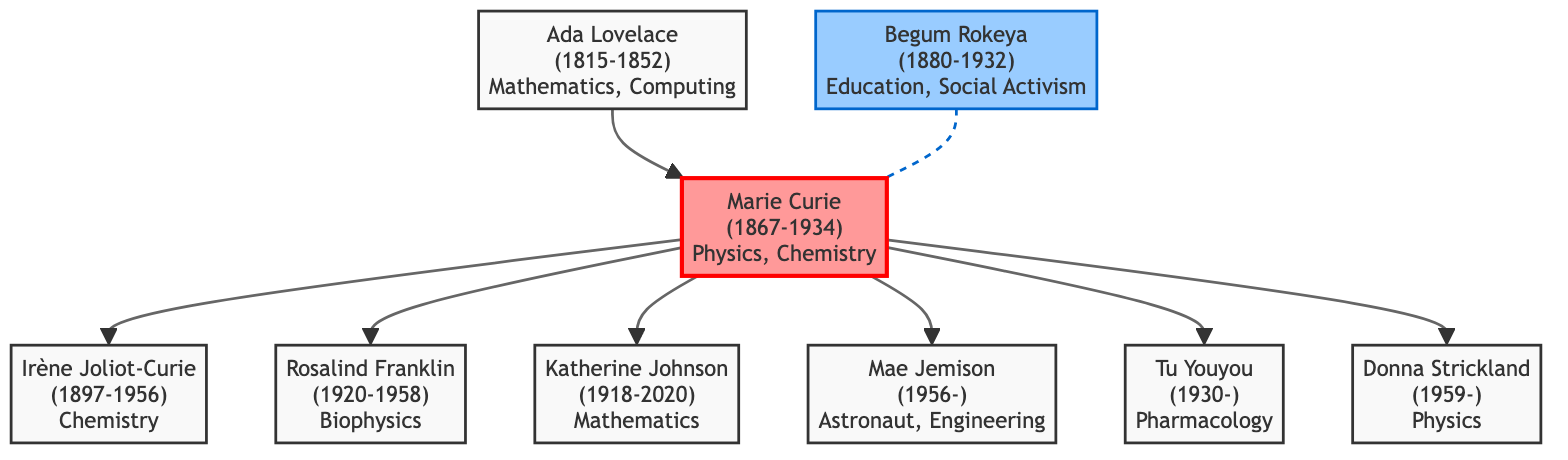What is the birth year of Marie Curie? The diagram lists Marie Curie as being born in 1867. This information can be found directly under her name in the central node of the family tree.
Answer: 1867 Who is the daughter of Marie Curie? The diagram indicates that Irène Joliot-Curie is the daughter of Marie Curie, as stated in the lineage connected to the central node.
Answer: Irène Joliot-Curie How many women are directly connected to Marie Curie in the family tree? Counting the direct descendants connected to Marie Curie, we see that there are six individuals: Irène Joliot-Curie, Rosalind Franklin, Katherine Johnson, Mae Jemison, Tu Youyou, and Donna Strickland.
Answer: Six What is the notable work of Rosalind Franklin? The diagram specifies that Rosalind Franklin's notable work is the "X-ray diffraction images of DNA." This can be found alongside her name within her node in the family tree.
Answer: X-ray diffraction images of DNA How are Ada Lovelace and Marie Curie related in this family tree? The diagram shows that Ada Lovelace is not a direct descendant but a pioneer who set foundational work for women in STEM, which influenced later scientists like Marie Curie. This relationship is indicated by an arrow that connects her to Marie Curie.
Answer: Pioneer; set foundational work for women in STEM What year did Katherine Johnson pass away? Referring to the diagram, Katherine Johnson is shown to have died in the year 2020, as indicated under her name in her corresponding node.
Answer: 2020 Who is the inspirational figure for women in STEM from Bangladesh? The diagram highlights Begum Rokeya as the inspirational figure for women in STEM from Bangladesh. This is provided in a separate node that discusses her significance.
Answer: Begum Rokeya What branch of science is Tu Youyou associated with? The family tree indicates that Tu Youyou is associated with the field of Pharmacology, showing her specific area of contribution in the diagram.
Answer: Pharmacology Which individual is recognized as the first African-American woman astronaut? The diagram identifies Mae Jemison as the first African-American woman astronaut, which is clearly stated in her node within the family tree.
Answer: Mae Jemison 